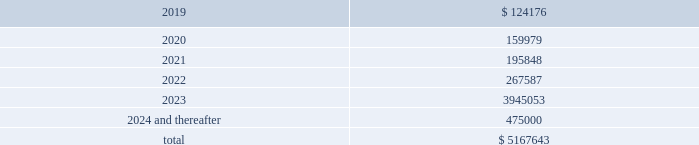Maturity requirements on long-term debt as of december 31 , 2018 by year are as follows ( in thousands ) : years ending december 31 .
Credit facility we are party to a credit facility agreement with bank of america , n.a. , as administrative agent , and a syndicate of financial institutions as lenders and other agents ( as amended from time to time , the 201ccredit facility 201d ) .
As of december 31 , 2018 , the credit facility provided for secured financing comprised of ( i ) a $ 1.5 billion revolving credit facility ( the 201crevolving credit facility 201d ) ; ( ii ) a $ 1.5 billion term loan ( the 201cterm a loan 201d ) , ( iii ) a $ 1.37 billion term loan ( the 201cterm a-2 loan 201d ) , ( iv ) a $ 1.14 billion term loan facility ( the 201cterm b-2 loan 201d ) and ( v ) a $ 500 million term loan ( the 201cterm b-4 loan 201d ) .
Substantially all of the assets of our domestic subsidiaries are pledged as collateral under the credit facility .
The borrowings outstanding under our credit facility as of december 31 , 2018 reflect amounts borrowed for acquisitions and other activities we completed in 2018 , including a reduction to the interest rate margins applicable to our term a loan , term a-2 loan , term b-2 loan and the revolving credit facility , an extension of the maturity dates of the term a loan , term a-2 loan and the revolving credit facility , and an increase in the total financing capacity under the credit facility to approximately $ 5.5 billion in june 2018 .
In october 2018 , we entered into an additional term loan under the credit facility in the amount of $ 500 million ( the 201cterm b-4 loan 201d ) .
We used the proceeds from the term b-4 loan to pay down a portion of the balance outstanding under our revolving credit facility .
The credit facility provides for an interest rate , at our election , of either libor or a base rate , in each case plus a margin .
As of december 31 , 2018 , the interest rates on the term a loan , the term a-2 loan , the term b-2 loan and the term b-4 loan were 4.02% ( 4.02 % ) , 4.01% ( 4.01 % ) , 4.27% ( 4.27 % ) and 4.27% ( 4.27 % ) , respectively , and the interest rate on the revolving credit facility was 3.92% ( 3.92 % ) .
In addition , we are required to pay a quarterly commitment fee with respect to the unused portion of the revolving credit facility at an applicable rate per annum ranging from 0.20% ( 0.20 % ) to 0.30% ( 0.30 % ) depending on our leverage ratio .
The term a loan and the term a-2 loan mature , and the revolving credit facility expires , on january 20 , 2023 .
The term b-2 loan matures on april 22 , 2023 .
The term b-4 loan matures on october 18 , 2025 .
The term a loan and term a-2 loan principal amounts must each be repaid in quarterly installments in the amount of 0.625% ( 0.625 % ) of principal through june 2019 , increasing to 1.25% ( 1.25 % ) of principal through june 2021 , increasing to 1.875% ( 1.875 % ) of principal through june 2022 and increasing to 2.50% ( 2.50 % ) of principal through december 2022 , with the remaining principal balance due upon maturity in january 2023 .
The term b-2 loan principal must be repaid in quarterly installments in the amount of 0.25% ( 0.25 % ) of principal through march 2023 , with the remaining principal balance due upon maturity in april 2023 .
The term b-4 loan principal must be repaid in quarterly installments in the amount of 0.25% ( 0.25 % ) of principal through september 2025 , with the remaining principal balance due upon maturity in october 2025 .
We may issue standby letters of credit of up to $ 100 million in the aggregate under the revolving credit facility .
Outstanding letters of credit under the revolving credit facility reduce the amount of borrowings available to us .
Borrowings available to us under the revolving credit facility are further limited by the covenants described below under 201ccompliance with covenants . 201d the total available commitments under the revolving credit facility at december 31 , 2018 were $ 783.6 million .
Global payments inc .
| 2018 form 10-k annual report 2013 85 .
How much did the annual payments increase from 2019 to 2024 and beyond? 
Rationale: the amount of interest increased each year and compounded therefore the payments went up 350824 thousand from 2019 to 2024 and beyond .
Computations: (475000 - 124176)
Answer: 350824.0. 